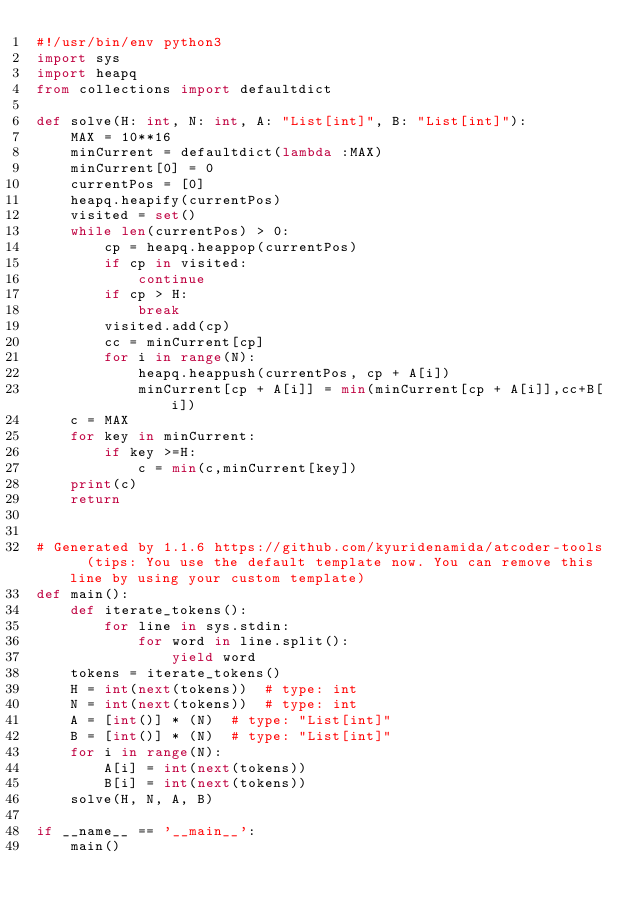<code> <loc_0><loc_0><loc_500><loc_500><_Python_>#!/usr/bin/env python3
import sys
import heapq
from collections import defaultdict

def solve(H: int, N: int, A: "List[int]", B: "List[int]"):
    MAX = 10**16
    minCurrent = defaultdict(lambda :MAX)
    minCurrent[0] = 0
    currentPos = [0]
    heapq.heapify(currentPos)
    visited = set()
    while len(currentPos) > 0:
        cp = heapq.heappop(currentPos)
        if cp in visited:
            continue
        if cp > H:
            break
        visited.add(cp)
        cc = minCurrent[cp]
        for i in range(N):
            heapq.heappush(currentPos, cp + A[i])
            minCurrent[cp + A[i]] = min(minCurrent[cp + A[i]],cc+B[i])
    c = MAX
    for key in minCurrent:
        if key >=H:
            c = min(c,minCurrent[key])
    print(c)
    return


# Generated by 1.1.6 https://github.com/kyuridenamida/atcoder-tools  (tips: You use the default template now. You can remove this line by using your custom template)
def main():
    def iterate_tokens():
        for line in sys.stdin:
            for word in line.split():
                yield word
    tokens = iterate_tokens()
    H = int(next(tokens))  # type: int
    N = int(next(tokens))  # type: int
    A = [int()] * (N)  # type: "List[int]"
    B = [int()] * (N)  # type: "List[int]"
    for i in range(N):
        A[i] = int(next(tokens))
        B[i] = int(next(tokens))
    solve(H, N, A, B)

if __name__ == '__main__':
    main()
</code> 